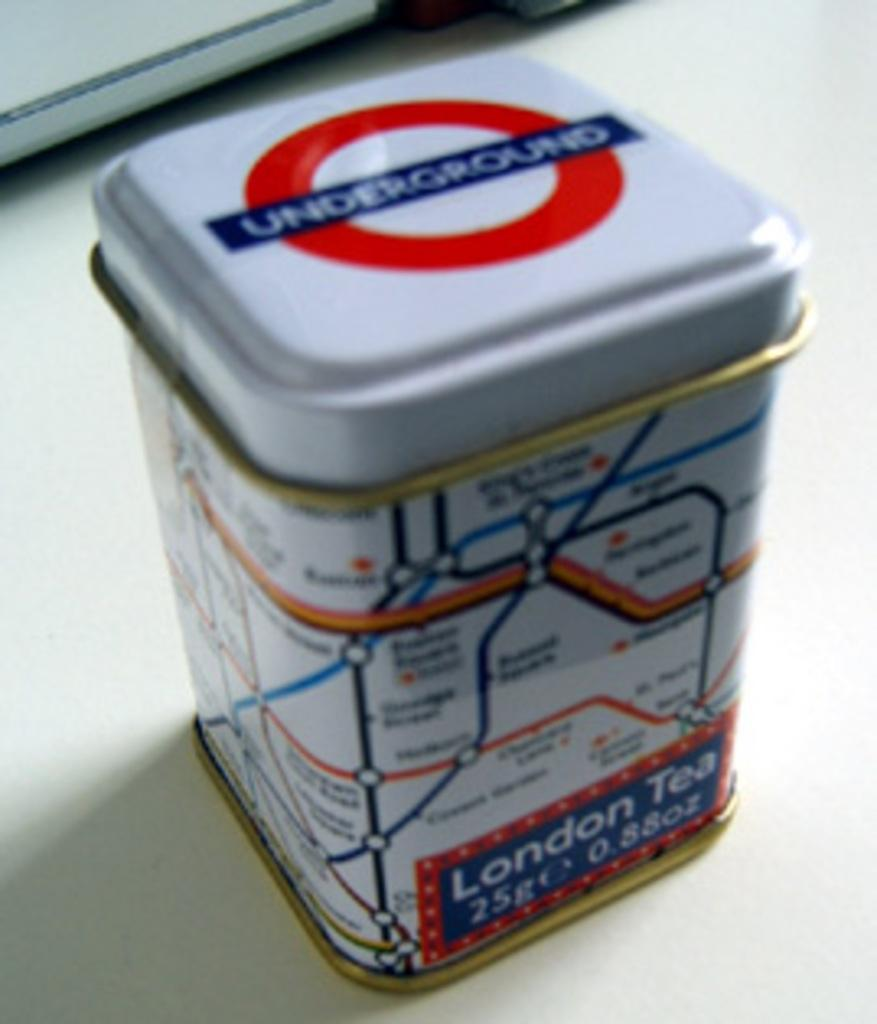<image>
Relay a brief, clear account of the picture shown. A can with a map on it that says London Tea. 